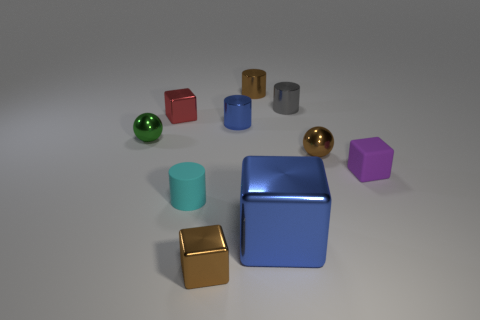Is there any other thing that is the same size as the blue cube?
Your answer should be compact. No. What number of objects are either tiny brown objects to the right of the blue cube or brown objects?
Provide a succinct answer. 3. The small red object that is made of the same material as the small brown block is what shape?
Provide a short and direct response. Cube. Is there any other thing that is the same shape as the big blue metal thing?
Ensure brevity in your answer.  Yes. The small block that is in front of the small blue object and left of the brown metallic cylinder is what color?
Your answer should be compact. Brown. How many blocks are big blue objects or gray objects?
Ensure brevity in your answer.  1. How many cyan cylinders have the same size as the brown cylinder?
Make the answer very short. 1. How many matte things are on the left side of the brown shiny object that is behind the tiny blue object?
Provide a succinct answer. 1. There is a metallic thing that is both in front of the tiny blue object and behind the tiny brown metallic sphere; what size is it?
Your response must be concise. Small. Is the number of tiny yellow metallic cylinders greater than the number of tiny brown metallic cubes?
Offer a terse response. No. 